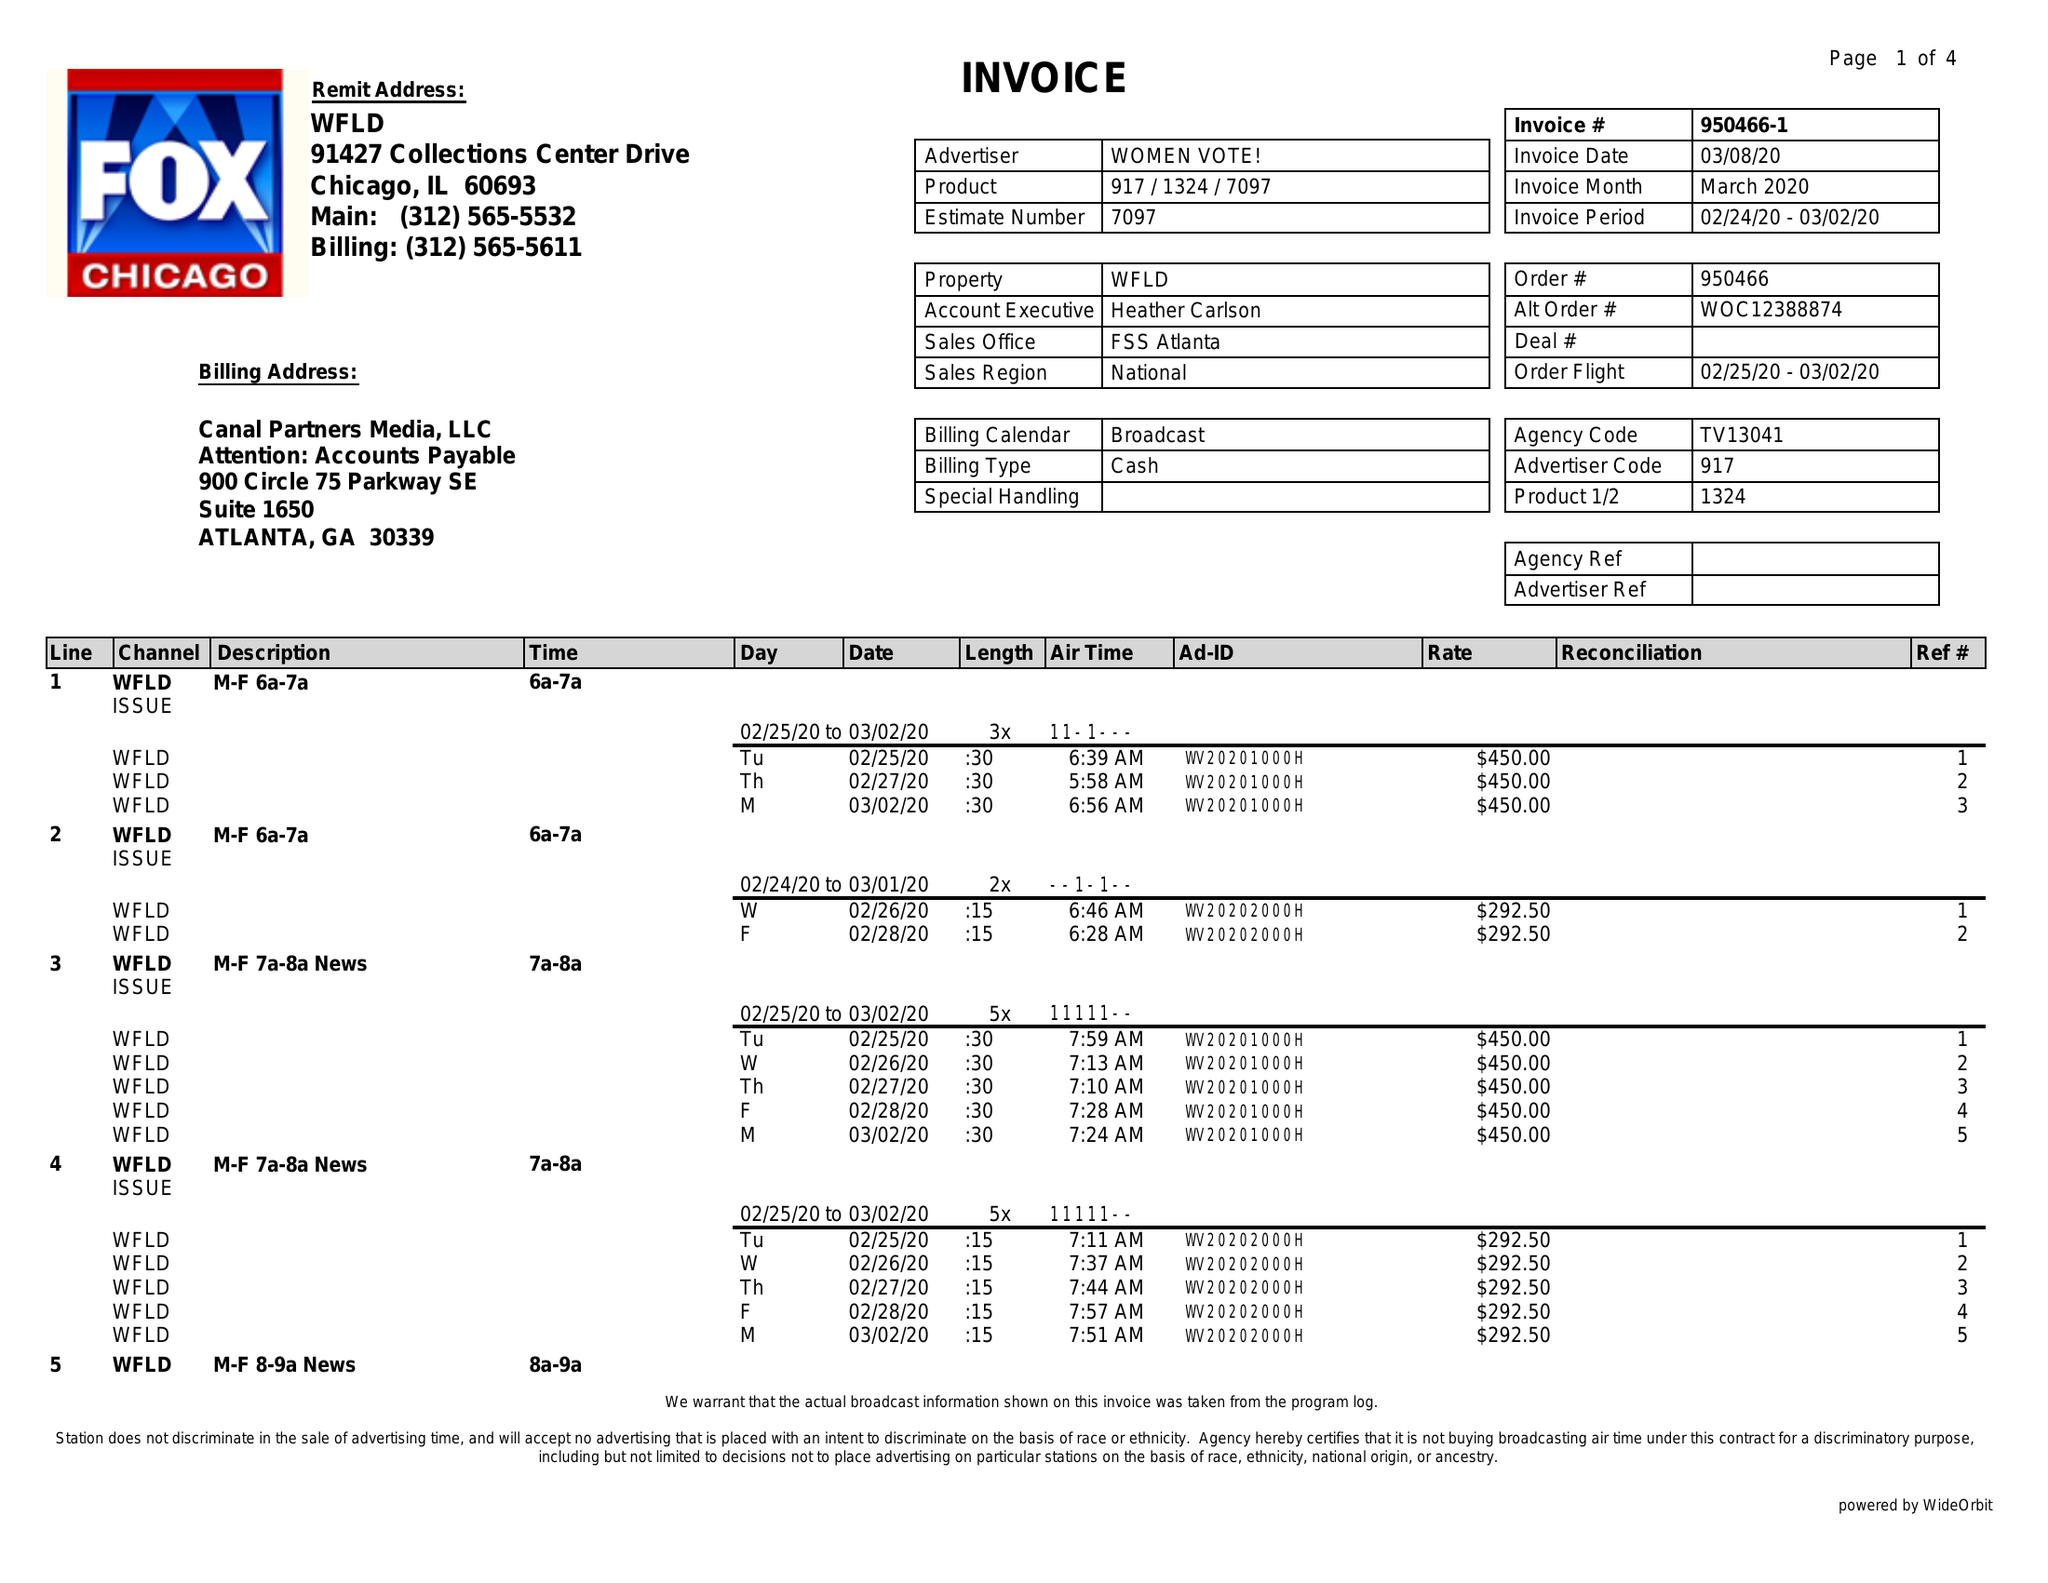What is the value for the flight_to?
Answer the question using a single word or phrase. 03/02/20 